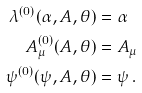<formula> <loc_0><loc_0><loc_500><loc_500>\lambda ^ { ( 0 ) } ( \alpha , A , \theta ) & = \alpha \\ A _ { \mu } ^ { ( 0 ) } ( A , \theta ) & = A _ { \mu } \\ \psi ^ { ( 0 ) } ( \psi , A , \theta ) & = \psi \, .</formula> 